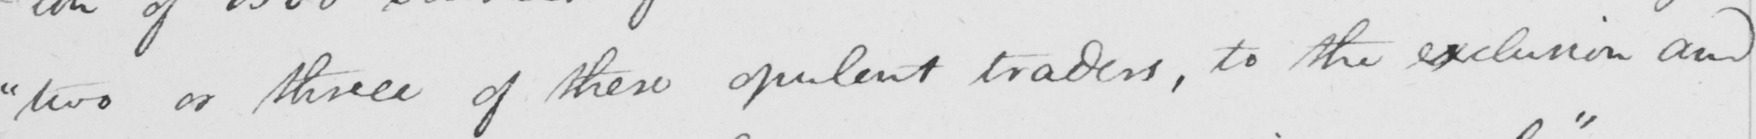What text is written in this handwritten line? " two or three of these opulent traders , to the exclusion and 